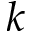Convert formula to latex. <formula><loc_0><loc_0><loc_500><loc_500>k</formula> 